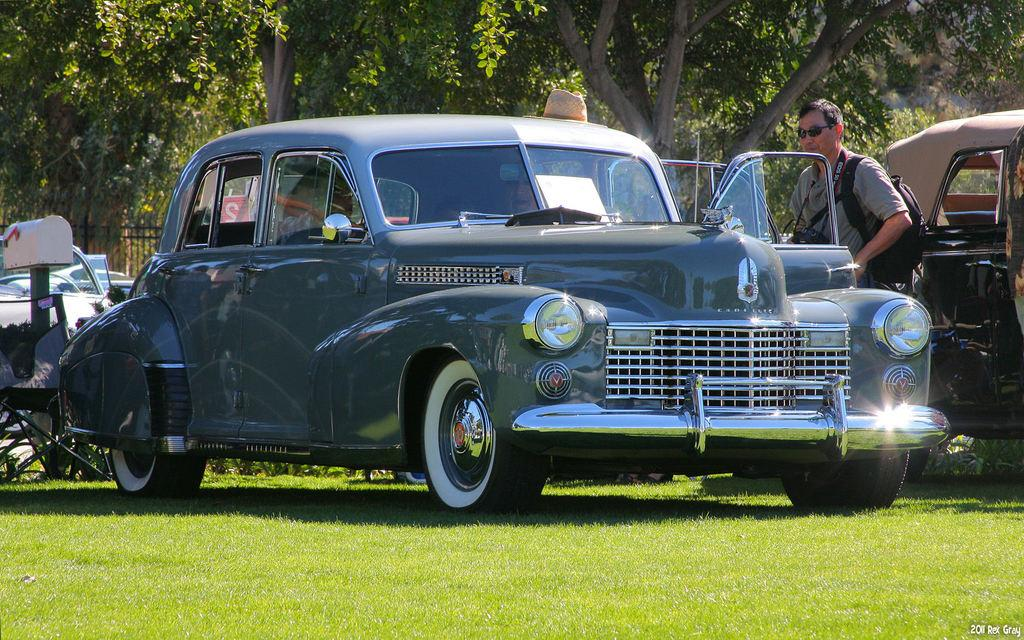What is the main subject of the image? The main subject of the image is cars on a grassland. Can you describe the man's position in the image? A man is standing beside a car in the image. What can be seen in the background of the image? There are trees in the background of the image. What sense does the tiger use to locate its prey in the image? There is no tiger present in the image, so it is not possible to determine which sense the tiger might use to locate its prey. 